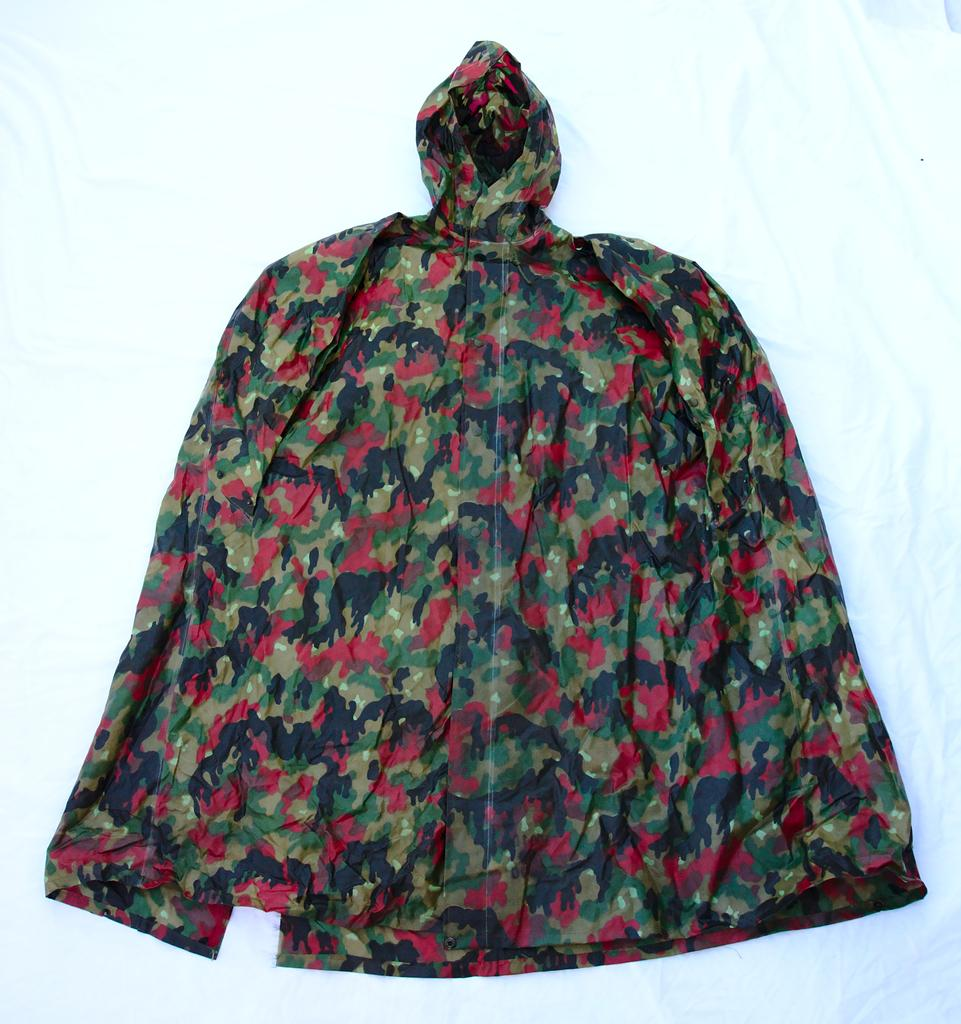What type of clothing is visible in the image? There is a raincoat in the image. What color is the background of the image? The background of the image is white. What type of lumber is being used to build the house in the image? There is no house or lumber present in the image; it only features a raincoat and a white background. 